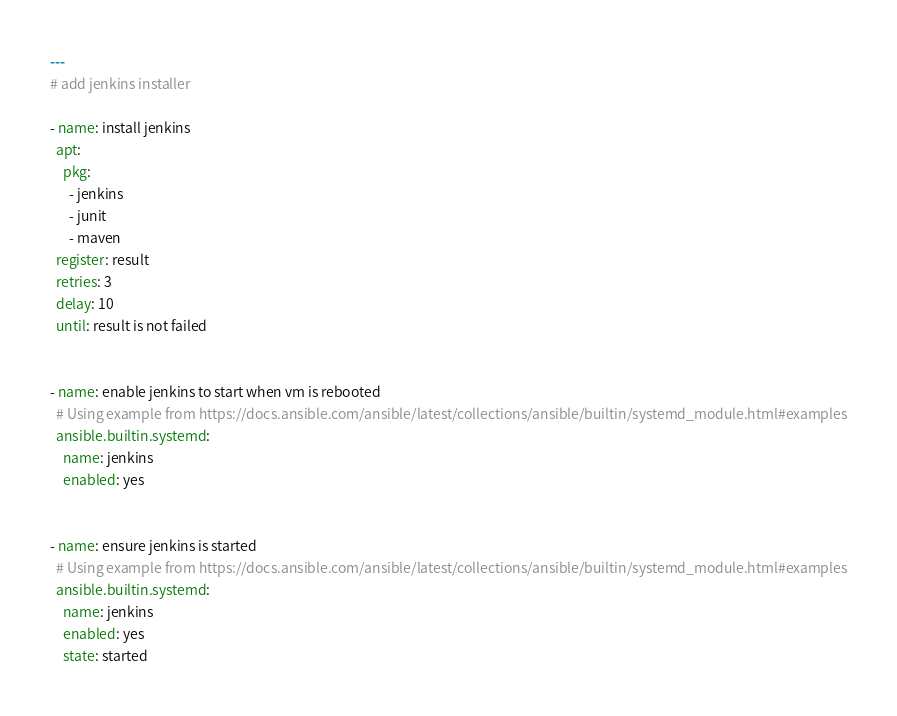<code> <loc_0><loc_0><loc_500><loc_500><_YAML_>---
# add jenkins installer

- name: install jenkins
  apt:
    pkg:
      - jenkins
      - junit
      - maven
  register: result
  retries: 3
  delay: 10
  until: result is not failed


- name: enable jenkins to start when vm is rebooted
  # Using example from https://docs.ansible.com/ansible/latest/collections/ansible/builtin/systemd_module.html#examples
  ansible.builtin.systemd:
    name: jenkins
    enabled: yes


- name: ensure jenkins is started
  # Using example from https://docs.ansible.com/ansible/latest/collections/ansible/builtin/systemd_module.html#examples
  ansible.builtin.systemd:
    name: jenkins
    enabled: yes
    state: started
</code> 